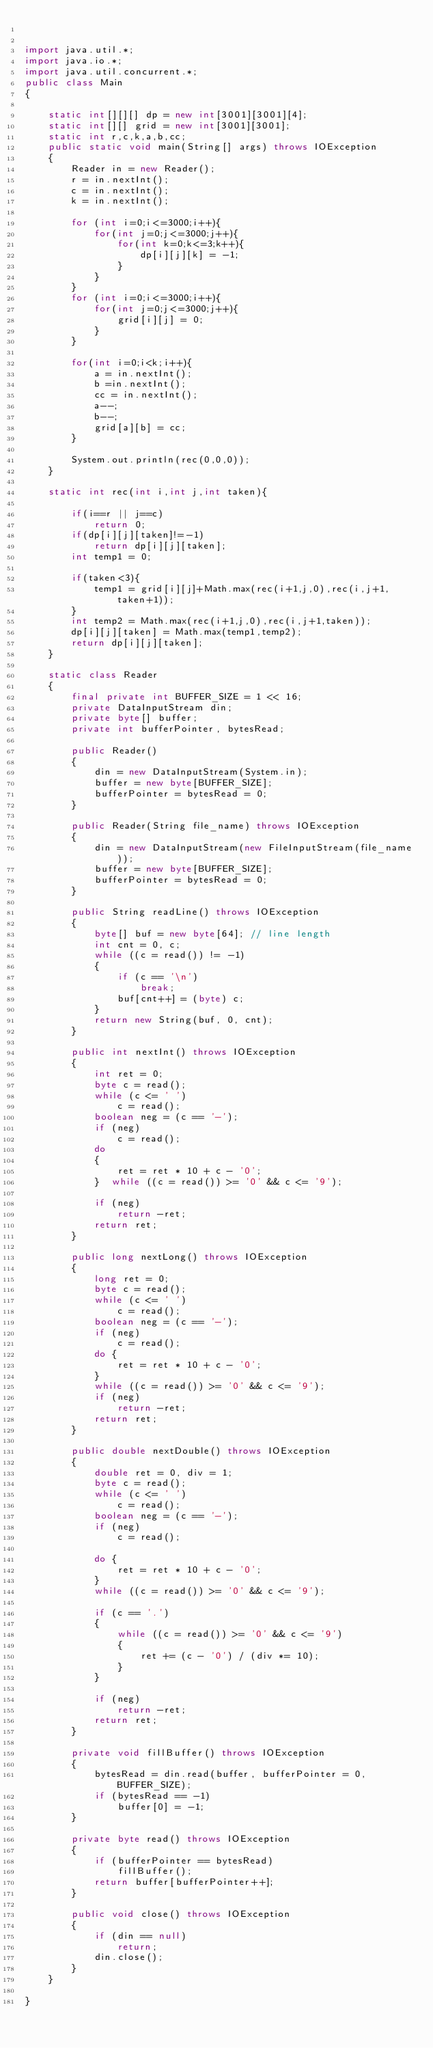<code> <loc_0><loc_0><loc_500><loc_500><_Java_>

import java.util.*;
import java.io.*;
import java.util.concurrent.*;
public class Main
{

    static int[][][] dp = new int[3001][3001][4];
    static int[][] grid = new int[3001][3001];
    static int r,c,k,a,b,cc;
    public static void main(String[] args) throws IOException
    {
        Reader in = new Reader();
        r = in.nextInt();
        c = in.nextInt();
        k = in.nextInt();

        for (int i=0;i<=3000;i++){
            for(int j=0;j<=3000;j++){
                for(int k=0;k<=3;k++){
                    dp[i][j][k] = -1;
                }
            }
        }
        for (int i=0;i<=3000;i++){
            for(int j=0;j<=3000;j++){
                grid[i][j] = 0;
            }
        }

        for(int i=0;i<k;i++){
            a = in.nextInt();
            b =in.nextInt();
            cc = in.nextInt();
            a--;
            b--;
            grid[a][b] = cc;
        }

        System.out.println(rec(0,0,0));
    }

    static int rec(int i,int j,int taken){

        if(i==r || j==c)
            return 0;
        if(dp[i][j][taken]!=-1)
            return dp[i][j][taken];
        int temp1 = 0;

        if(taken<3){
            temp1 = grid[i][j]+Math.max(rec(i+1,j,0),rec(i,j+1,taken+1));
        }
        int temp2 = Math.max(rec(i+1,j,0),rec(i,j+1,taken));
        dp[i][j][taken] = Math.max(temp1,temp2);
        return dp[i][j][taken];
    }

    static class Reader
    {
        final private int BUFFER_SIZE = 1 << 16;
        private DataInputStream din;
        private byte[] buffer;
        private int bufferPointer, bytesRead;

        public Reader()
        {
            din = new DataInputStream(System.in);
            buffer = new byte[BUFFER_SIZE];
            bufferPointer = bytesRead = 0;
        }

        public Reader(String file_name) throws IOException
        {
            din = new DataInputStream(new FileInputStream(file_name));
            buffer = new byte[BUFFER_SIZE];
            bufferPointer = bytesRead = 0;
        }

        public String readLine() throws IOException
        {
            byte[] buf = new byte[64]; // line length
            int cnt = 0, c;
            while ((c = read()) != -1)
            {
                if (c == '\n')
                    break;
                buf[cnt++] = (byte) c;
            }
            return new String(buf, 0, cnt);
        }

        public int nextInt() throws IOException
        {
            int ret = 0;
            byte c = read();
            while (c <= ' ')
                c = read();
            boolean neg = (c == '-');
            if (neg)
                c = read();
            do
            {
                ret = ret * 10 + c - '0';
            }  while ((c = read()) >= '0' && c <= '9');

            if (neg)
                return -ret;
            return ret;
        }

        public long nextLong() throws IOException
        {
            long ret = 0;
            byte c = read();
            while (c <= ' ')
                c = read();
            boolean neg = (c == '-');
            if (neg)
                c = read();
            do {
                ret = ret * 10 + c - '0';
            }
            while ((c = read()) >= '0' && c <= '9');
            if (neg)
                return -ret;
            return ret;
        }

        public double nextDouble() throws IOException
        {
            double ret = 0, div = 1;
            byte c = read();
            while (c <= ' ')
                c = read();
            boolean neg = (c == '-');
            if (neg)
                c = read();

            do {
                ret = ret * 10 + c - '0';
            }
            while ((c = read()) >= '0' && c <= '9');

            if (c == '.')
            {
                while ((c = read()) >= '0' && c <= '9')
                {
                    ret += (c - '0') / (div *= 10);
                }
            }

            if (neg)
                return -ret;
            return ret;
        }

        private void fillBuffer() throws IOException
        {
            bytesRead = din.read(buffer, bufferPointer = 0, BUFFER_SIZE);
            if (bytesRead == -1)
                buffer[0] = -1;
        }

        private byte read() throws IOException
        {
            if (bufferPointer == bytesRead)
                fillBuffer();
            return buffer[bufferPointer++];
        }

        public void close() throws IOException
        {
            if (din == null)
                return;
            din.close();
        }
    }

}</code> 